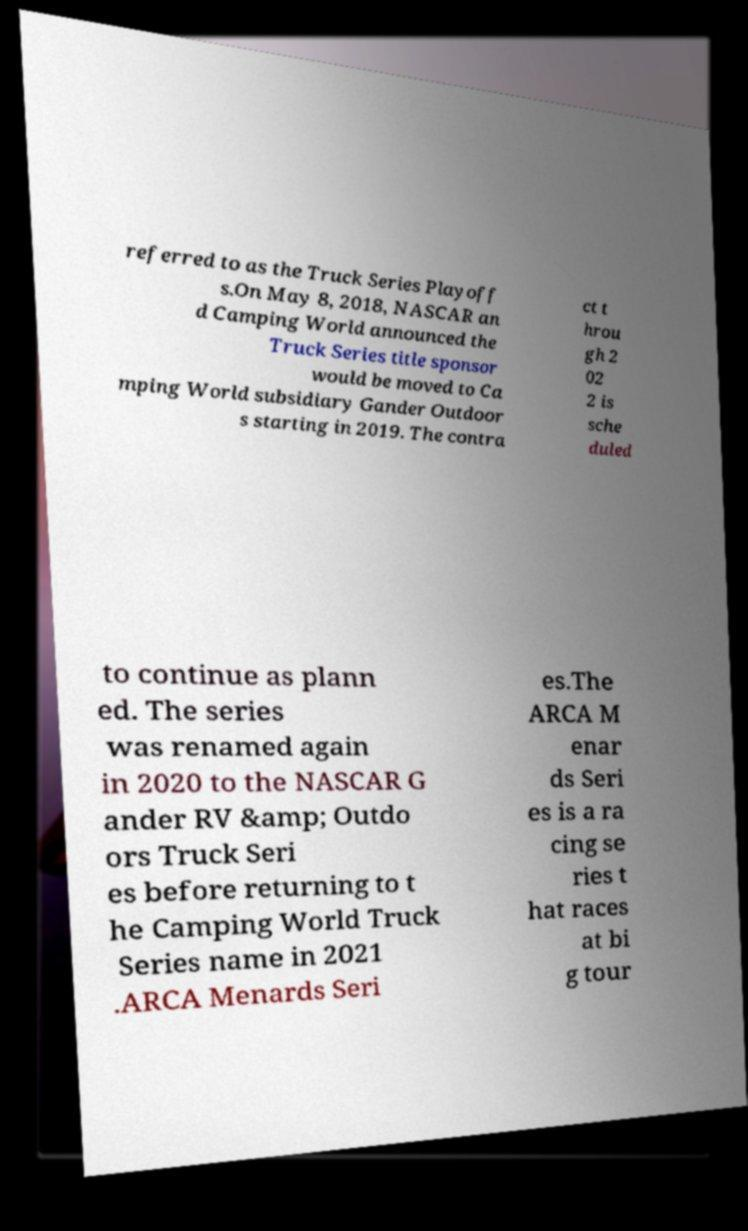Please identify and transcribe the text found in this image. referred to as the Truck Series Playoff s.On May 8, 2018, NASCAR an d Camping World announced the Truck Series title sponsor would be moved to Ca mping World subsidiary Gander Outdoor s starting in 2019. The contra ct t hrou gh 2 02 2 is sche duled to continue as plann ed. The series was renamed again in 2020 to the NASCAR G ander RV &amp; Outdo ors Truck Seri es before returning to t he Camping World Truck Series name in 2021 .ARCA Menards Seri es.The ARCA M enar ds Seri es is a ra cing se ries t hat races at bi g tour 